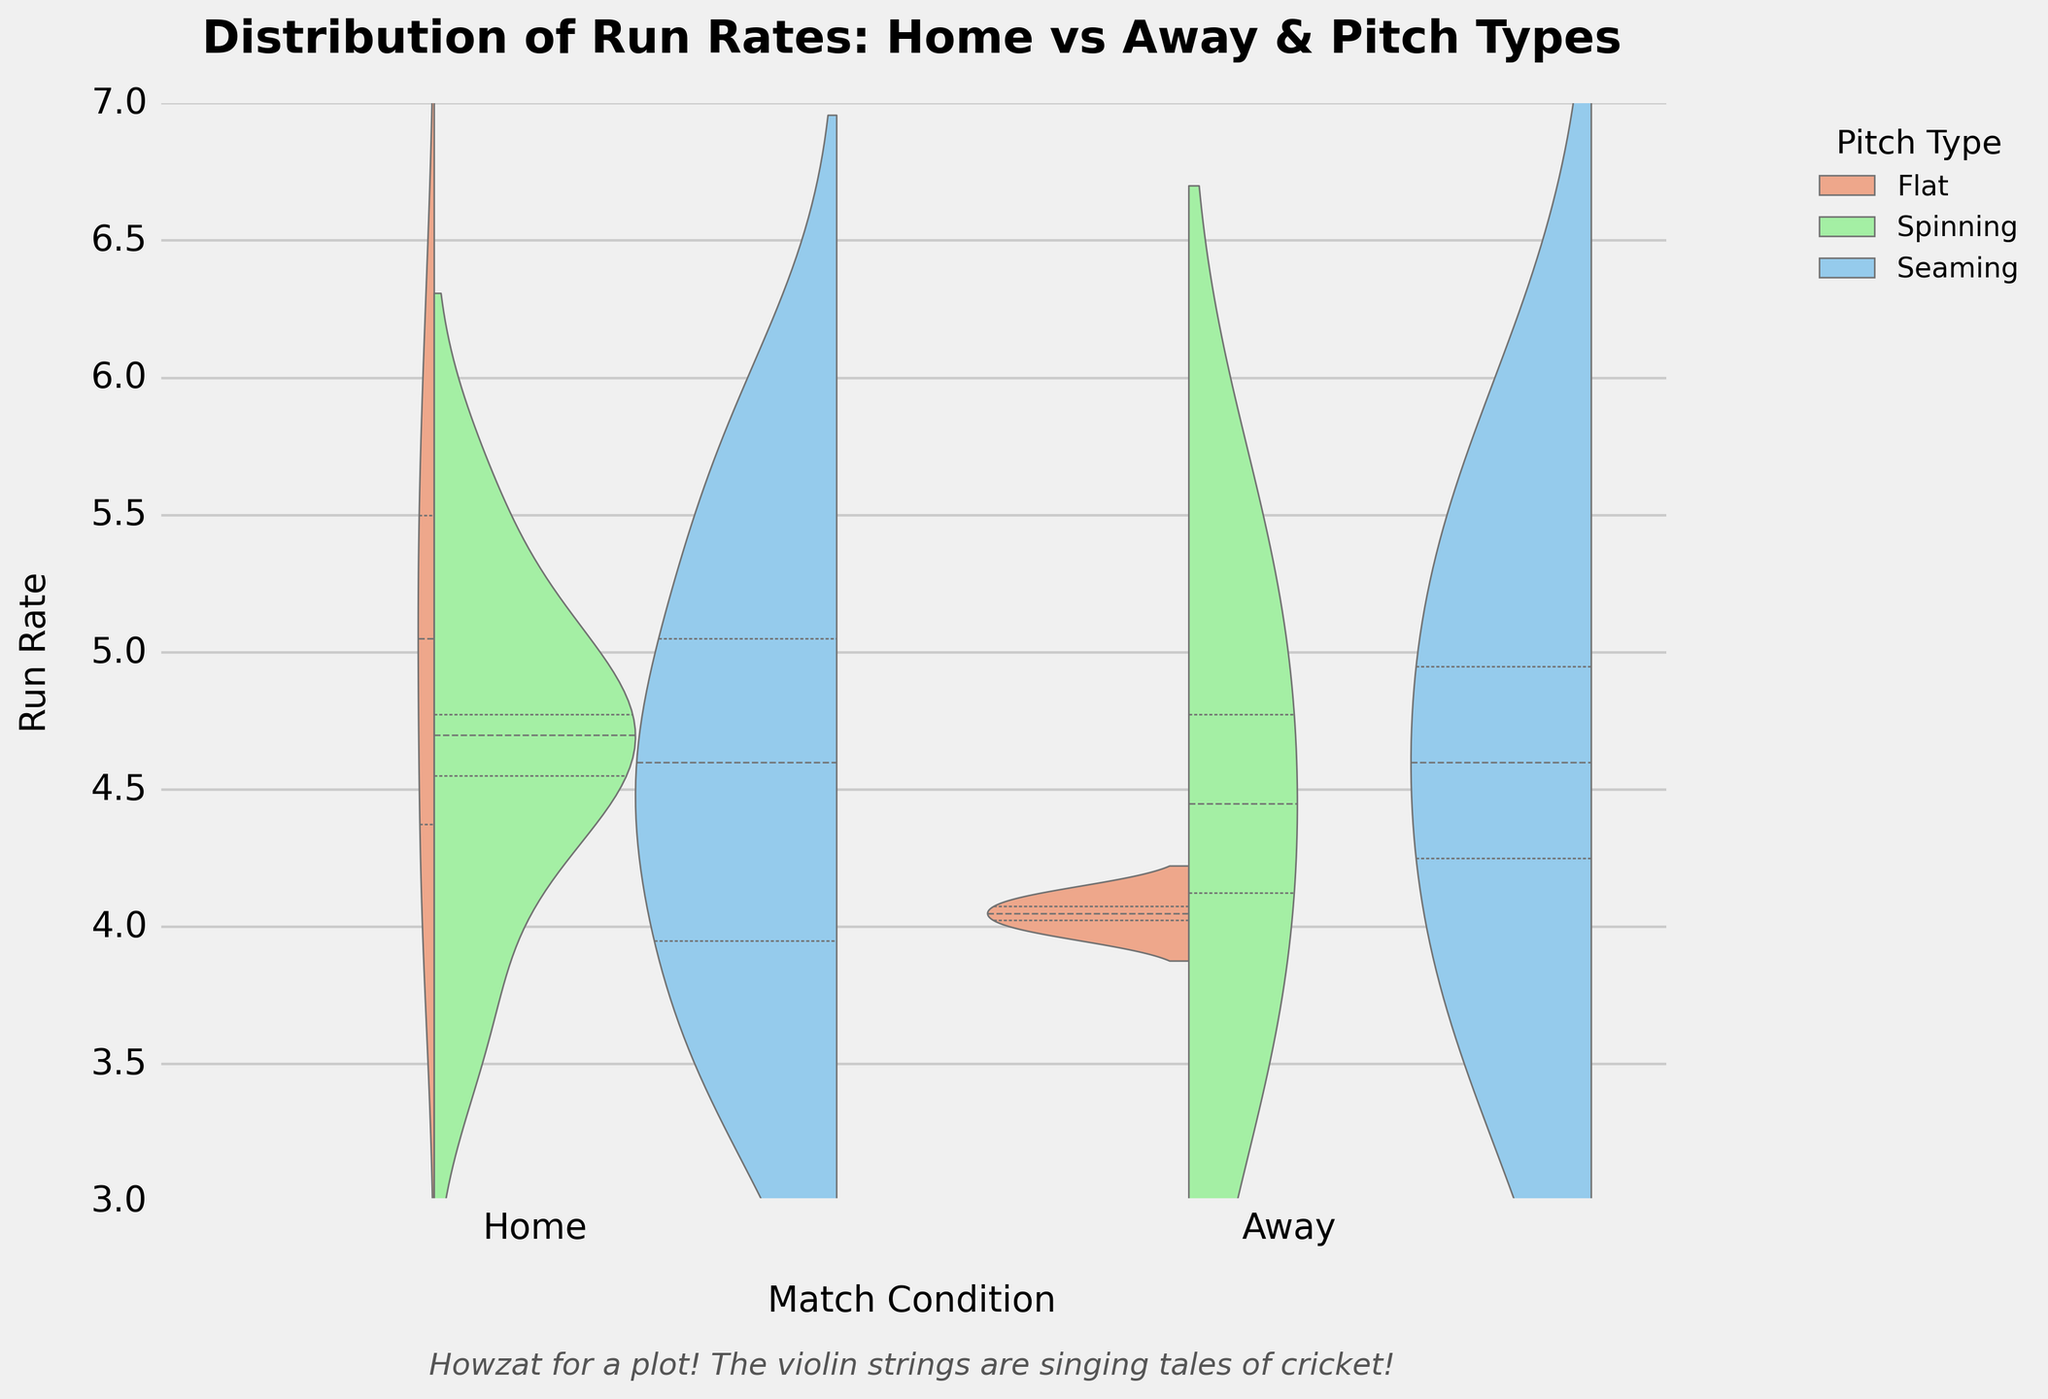What is the title of the figure? The title is usually displayed at the top of the figure. In this case, it mentions "Distribution of Run Rates: Home vs Away & Pitch Types."
Answer: Distribution of Run Rates: Home vs Away & Pitch Types What are the different pitch types represented in the figure? The legend indicates the different pitch types using colors. The pitch types shown are Flat, Spinning, and Seaming.
Answer: Flat, Spinning, Seaming Which condition (Home or Away) shows a wider distribution of run rates? By observing the width and spread of the violin plots, the distributions for Home conditions appear wider and more spread out compared to Away conditions.
Answer: Home In which condition do you observe a higher median run rate? The inner quartile lines within the violin plot give a hint about medians. There is a higher median run rate in Home conditions compared to Away.
Answer: Home For the Flat pitch type, which condition has a higher run rate distribution? Comparing the Flat pitch type distribution, Home conditions show a higher concentration and spread of run rates than Away.
Answer: Home What's the range of run rates observed for games played in Home conditions with Spinning pitch types? The range can be seen from the spread of the violin plot. For Home conditions with Spinning pitch types, the run rate ranges approximately from 3.5 to 5.5.
Answer: 3.5 to 5.5 How does the run rate distribution in Away conditions with Seaming pitches compare to Flat pitches? Seaming pitches in Away conditions show a tighter distribution, with most values around the median, while Flat pitches have a slightly wider distribution but lower median.
Answer: Tighter and more concentrated for Seaming Which pitch type shows the least variability in run rate for Home conditions? By examining the width of the violin plots for Home conditions, the Seaming pitch type has the narrowest distribution, indicating the least variability.
Answer: Seaming What run rate value is common across most pitch types in Home conditions? Observing where the violin plots overlap or show intense density, around 4.7 seems to be a common run rate value across different pitch types in Home conditions.
Answer: 4.7 How does the distribution of run rates in Home conditions for Spinning pitches compare to Away conditions for the same pitch? The Home conditions for Spinning pitches display a wider and slightly higher distribution of run rates compared to the narrower, more centralized distribution in Away conditions.
Answer: Wider and higher for Home 